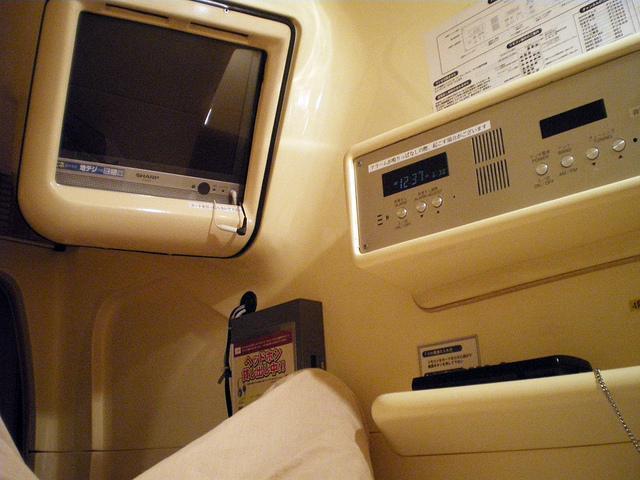How many windshield wipers does the train have?
Give a very brief answer. 0. 